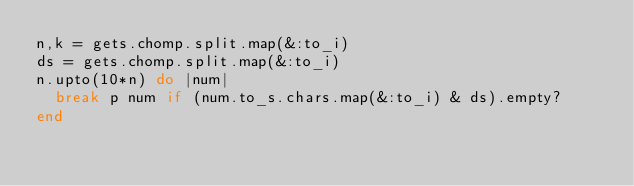<code> <loc_0><loc_0><loc_500><loc_500><_Ruby_>n,k = gets.chomp.split.map(&:to_i)
ds = gets.chomp.split.map(&:to_i)
n.upto(10*n) do |num|
  break p num if (num.to_s.chars.map(&:to_i) & ds).empty?
end
</code> 